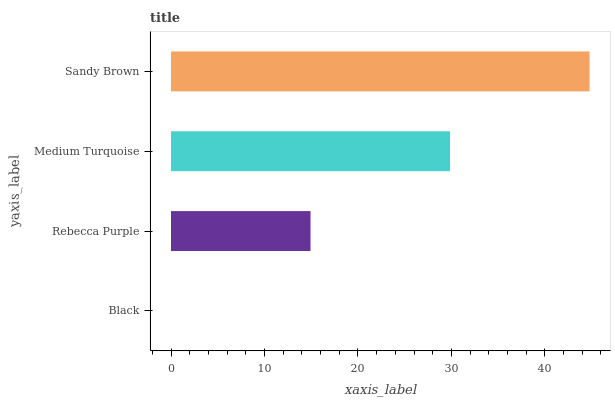Is Black the minimum?
Answer yes or no. Yes. Is Sandy Brown the maximum?
Answer yes or no. Yes. Is Rebecca Purple the minimum?
Answer yes or no. No. Is Rebecca Purple the maximum?
Answer yes or no. No. Is Rebecca Purple greater than Black?
Answer yes or no. Yes. Is Black less than Rebecca Purple?
Answer yes or no. Yes. Is Black greater than Rebecca Purple?
Answer yes or no. No. Is Rebecca Purple less than Black?
Answer yes or no. No. Is Medium Turquoise the high median?
Answer yes or no. Yes. Is Rebecca Purple the low median?
Answer yes or no. Yes. Is Sandy Brown the high median?
Answer yes or no. No. Is Sandy Brown the low median?
Answer yes or no. No. 